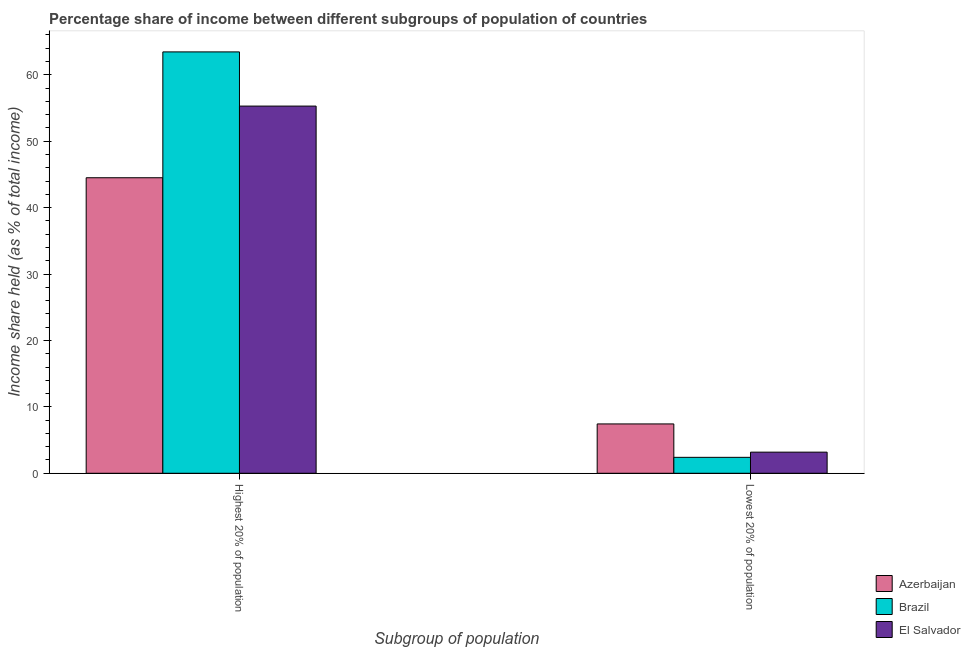How many different coloured bars are there?
Give a very brief answer. 3. Are the number of bars per tick equal to the number of legend labels?
Keep it short and to the point. Yes. How many bars are there on the 1st tick from the left?
Offer a terse response. 3. How many bars are there on the 1st tick from the right?
Provide a succinct answer. 3. What is the label of the 1st group of bars from the left?
Offer a terse response. Highest 20% of population. What is the income share held by highest 20% of the population in El Salvador?
Provide a succinct answer. 55.29. Across all countries, what is the maximum income share held by lowest 20% of the population?
Keep it short and to the point. 7.43. Across all countries, what is the minimum income share held by highest 20% of the population?
Give a very brief answer. 44.5. In which country was the income share held by highest 20% of the population maximum?
Your answer should be compact. Brazil. What is the total income share held by highest 20% of the population in the graph?
Offer a terse response. 163.24. What is the difference between the income share held by lowest 20% of the population in Brazil and that in El Salvador?
Keep it short and to the point. -0.78. What is the difference between the income share held by highest 20% of the population in Azerbaijan and the income share held by lowest 20% of the population in El Salvador?
Keep it short and to the point. 41.32. What is the average income share held by lowest 20% of the population per country?
Give a very brief answer. 4.34. What is the difference between the income share held by lowest 20% of the population and income share held by highest 20% of the population in Brazil?
Provide a short and direct response. -61.05. In how many countries, is the income share held by lowest 20% of the population greater than 48 %?
Your answer should be very brief. 0. What is the ratio of the income share held by lowest 20% of the population in El Salvador to that in Azerbaijan?
Provide a short and direct response. 0.43. In how many countries, is the income share held by highest 20% of the population greater than the average income share held by highest 20% of the population taken over all countries?
Your answer should be compact. 2. What does the 3rd bar from the left in Highest 20% of population represents?
Your answer should be very brief. El Salvador. How many bars are there?
Your answer should be very brief. 6. Are all the bars in the graph horizontal?
Make the answer very short. No. How many countries are there in the graph?
Your response must be concise. 3. Are the values on the major ticks of Y-axis written in scientific E-notation?
Your response must be concise. No. How many legend labels are there?
Your answer should be compact. 3. What is the title of the graph?
Offer a terse response. Percentage share of income between different subgroups of population of countries. What is the label or title of the X-axis?
Your answer should be compact. Subgroup of population. What is the label or title of the Y-axis?
Offer a terse response. Income share held (as % of total income). What is the Income share held (as % of total income) of Azerbaijan in Highest 20% of population?
Keep it short and to the point. 44.5. What is the Income share held (as % of total income) in Brazil in Highest 20% of population?
Give a very brief answer. 63.45. What is the Income share held (as % of total income) of El Salvador in Highest 20% of population?
Ensure brevity in your answer.  55.29. What is the Income share held (as % of total income) of Azerbaijan in Lowest 20% of population?
Your response must be concise. 7.43. What is the Income share held (as % of total income) in El Salvador in Lowest 20% of population?
Give a very brief answer. 3.18. Across all Subgroup of population, what is the maximum Income share held (as % of total income) in Azerbaijan?
Provide a short and direct response. 44.5. Across all Subgroup of population, what is the maximum Income share held (as % of total income) in Brazil?
Your answer should be very brief. 63.45. Across all Subgroup of population, what is the maximum Income share held (as % of total income) in El Salvador?
Provide a short and direct response. 55.29. Across all Subgroup of population, what is the minimum Income share held (as % of total income) in Azerbaijan?
Make the answer very short. 7.43. Across all Subgroup of population, what is the minimum Income share held (as % of total income) of Brazil?
Offer a terse response. 2.4. Across all Subgroup of population, what is the minimum Income share held (as % of total income) of El Salvador?
Keep it short and to the point. 3.18. What is the total Income share held (as % of total income) in Azerbaijan in the graph?
Give a very brief answer. 51.93. What is the total Income share held (as % of total income) in Brazil in the graph?
Your response must be concise. 65.85. What is the total Income share held (as % of total income) in El Salvador in the graph?
Give a very brief answer. 58.47. What is the difference between the Income share held (as % of total income) in Azerbaijan in Highest 20% of population and that in Lowest 20% of population?
Your answer should be very brief. 37.07. What is the difference between the Income share held (as % of total income) in Brazil in Highest 20% of population and that in Lowest 20% of population?
Ensure brevity in your answer.  61.05. What is the difference between the Income share held (as % of total income) in El Salvador in Highest 20% of population and that in Lowest 20% of population?
Offer a very short reply. 52.11. What is the difference between the Income share held (as % of total income) of Azerbaijan in Highest 20% of population and the Income share held (as % of total income) of Brazil in Lowest 20% of population?
Offer a very short reply. 42.1. What is the difference between the Income share held (as % of total income) in Azerbaijan in Highest 20% of population and the Income share held (as % of total income) in El Salvador in Lowest 20% of population?
Your answer should be compact. 41.32. What is the difference between the Income share held (as % of total income) of Brazil in Highest 20% of population and the Income share held (as % of total income) of El Salvador in Lowest 20% of population?
Make the answer very short. 60.27. What is the average Income share held (as % of total income) in Azerbaijan per Subgroup of population?
Offer a terse response. 25.96. What is the average Income share held (as % of total income) in Brazil per Subgroup of population?
Your response must be concise. 32.92. What is the average Income share held (as % of total income) in El Salvador per Subgroup of population?
Keep it short and to the point. 29.23. What is the difference between the Income share held (as % of total income) in Azerbaijan and Income share held (as % of total income) in Brazil in Highest 20% of population?
Keep it short and to the point. -18.95. What is the difference between the Income share held (as % of total income) of Azerbaijan and Income share held (as % of total income) of El Salvador in Highest 20% of population?
Your answer should be compact. -10.79. What is the difference between the Income share held (as % of total income) in Brazil and Income share held (as % of total income) in El Salvador in Highest 20% of population?
Your answer should be very brief. 8.16. What is the difference between the Income share held (as % of total income) of Azerbaijan and Income share held (as % of total income) of Brazil in Lowest 20% of population?
Give a very brief answer. 5.03. What is the difference between the Income share held (as % of total income) in Azerbaijan and Income share held (as % of total income) in El Salvador in Lowest 20% of population?
Your answer should be very brief. 4.25. What is the difference between the Income share held (as % of total income) of Brazil and Income share held (as % of total income) of El Salvador in Lowest 20% of population?
Provide a succinct answer. -0.78. What is the ratio of the Income share held (as % of total income) of Azerbaijan in Highest 20% of population to that in Lowest 20% of population?
Offer a terse response. 5.99. What is the ratio of the Income share held (as % of total income) of Brazil in Highest 20% of population to that in Lowest 20% of population?
Ensure brevity in your answer.  26.44. What is the ratio of the Income share held (as % of total income) of El Salvador in Highest 20% of population to that in Lowest 20% of population?
Make the answer very short. 17.39. What is the difference between the highest and the second highest Income share held (as % of total income) of Azerbaijan?
Provide a short and direct response. 37.07. What is the difference between the highest and the second highest Income share held (as % of total income) in Brazil?
Your answer should be compact. 61.05. What is the difference between the highest and the second highest Income share held (as % of total income) of El Salvador?
Provide a short and direct response. 52.11. What is the difference between the highest and the lowest Income share held (as % of total income) in Azerbaijan?
Provide a short and direct response. 37.07. What is the difference between the highest and the lowest Income share held (as % of total income) of Brazil?
Your response must be concise. 61.05. What is the difference between the highest and the lowest Income share held (as % of total income) of El Salvador?
Offer a very short reply. 52.11. 